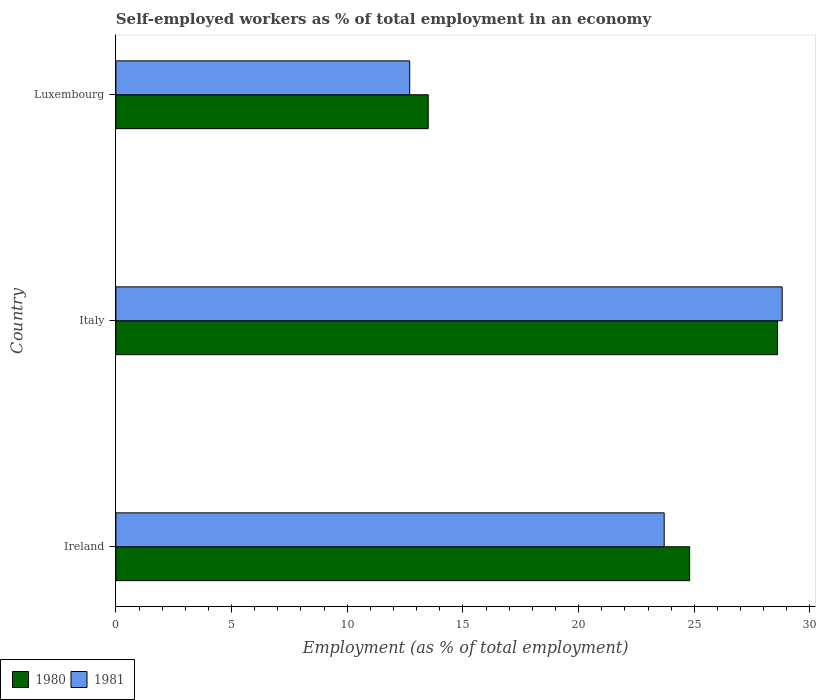How many different coloured bars are there?
Your response must be concise. 2. Are the number of bars per tick equal to the number of legend labels?
Provide a succinct answer. Yes. Are the number of bars on each tick of the Y-axis equal?
Ensure brevity in your answer.  Yes. What is the percentage of self-employed workers in 1980 in Italy?
Give a very brief answer. 28.6. Across all countries, what is the maximum percentage of self-employed workers in 1981?
Make the answer very short. 28.8. Across all countries, what is the minimum percentage of self-employed workers in 1980?
Provide a succinct answer. 13.5. In which country was the percentage of self-employed workers in 1980 maximum?
Keep it short and to the point. Italy. In which country was the percentage of self-employed workers in 1980 minimum?
Offer a terse response. Luxembourg. What is the total percentage of self-employed workers in 1980 in the graph?
Ensure brevity in your answer.  66.9. What is the difference between the percentage of self-employed workers in 1980 in Ireland and that in Italy?
Your answer should be compact. -3.8. What is the difference between the percentage of self-employed workers in 1981 in Luxembourg and the percentage of self-employed workers in 1980 in Italy?
Give a very brief answer. -15.9. What is the average percentage of self-employed workers in 1981 per country?
Ensure brevity in your answer.  21.73. What is the difference between the percentage of self-employed workers in 1980 and percentage of self-employed workers in 1981 in Italy?
Keep it short and to the point. -0.2. What is the ratio of the percentage of self-employed workers in 1980 in Italy to that in Luxembourg?
Provide a short and direct response. 2.12. Is the percentage of self-employed workers in 1981 in Italy less than that in Luxembourg?
Make the answer very short. No. What is the difference between the highest and the second highest percentage of self-employed workers in 1980?
Make the answer very short. 3.8. What is the difference between the highest and the lowest percentage of self-employed workers in 1980?
Offer a very short reply. 15.1. In how many countries, is the percentage of self-employed workers in 1981 greater than the average percentage of self-employed workers in 1981 taken over all countries?
Your answer should be very brief. 2. Is the sum of the percentage of self-employed workers in 1980 in Ireland and Luxembourg greater than the maximum percentage of self-employed workers in 1981 across all countries?
Your answer should be compact. Yes. What does the 1st bar from the top in Ireland represents?
Offer a very short reply. 1981. What does the 2nd bar from the bottom in Italy represents?
Make the answer very short. 1981. How many bars are there?
Give a very brief answer. 6. Are all the bars in the graph horizontal?
Give a very brief answer. Yes. Does the graph contain any zero values?
Your answer should be very brief. No. Does the graph contain grids?
Offer a very short reply. No. Where does the legend appear in the graph?
Keep it short and to the point. Bottom left. How are the legend labels stacked?
Provide a succinct answer. Horizontal. What is the title of the graph?
Offer a very short reply. Self-employed workers as % of total employment in an economy. What is the label or title of the X-axis?
Ensure brevity in your answer.  Employment (as % of total employment). What is the label or title of the Y-axis?
Your response must be concise. Country. What is the Employment (as % of total employment) of 1980 in Ireland?
Ensure brevity in your answer.  24.8. What is the Employment (as % of total employment) in 1981 in Ireland?
Keep it short and to the point. 23.7. What is the Employment (as % of total employment) in 1980 in Italy?
Keep it short and to the point. 28.6. What is the Employment (as % of total employment) of 1981 in Italy?
Provide a succinct answer. 28.8. What is the Employment (as % of total employment) of 1980 in Luxembourg?
Ensure brevity in your answer.  13.5. What is the Employment (as % of total employment) in 1981 in Luxembourg?
Your answer should be very brief. 12.7. Across all countries, what is the maximum Employment (as % of total employment) in 1980?
Give a very brief answer. 28.6. Across all countries, what is the maximum Employment (as % of total employment) of 1981?
Your answer should be compact. 28.8. Across all countries, what is the minimum Employment (as % of total employment) in 1980?
Provide a short and direct response. 13.5. Across all countries, what is the minimum Employment (as % of total employment) of 1981?
Ensure brevity in your answer.  12.7. What is the total Employment (as % of total employment) of 1980 in the graph?
Your answer should be very brief. 66.9. What is the total Employment (as % of total employment) in 1981 in the graph?
Your response must be concise. 65.2. What is the difference between the Employment (as % of total employment) in 1980 in Ireland and that in Italy?
Your answer should be very brief. -3.8. What is the difference between the Employment (as % of total employment) of 1981 in Ireland and that in Italy?
Provide a succinct answer. -5.1. What is the difference between the Employment (as % of total employment) in 1980 in Italy and that in Luxembourg?
Keep it short and to the point. 15.1. What is the difference between the Employment (as % of total employment) in 1981 in Italy and that in Luxembourg?
Make the answer very short. 16.1. What is the difference between the Employment (as % of total employment) of 1980 in Italy and the Employment (as % of total employment) of 1981 in Luxembourg?
Your answer should be very brief. 15.9. What is the average Employment (as % of total employment) in 1980 per country?
Provide a short and direct response. 22.3. What is the average Employment (as % of total employment) in 1981 per country?
Offer a very short reply. 21.73. What is the difference between the Employment (as % of total employment) of 1980 and Employment (as % of total employment) of 1981 in Ireland?
Your answer should be compact. 1.1. What is the difference between the Employment (as % of total employment) of 1980 and Employment (as % of total employment) of 1981 in Italy?
Offer a terse response. -0.2. What is the difference between the Employment (as % of total employment) in 1980 and Employment (as % of total employment) in 1981 in Luxembourg?
Give a very brief answer. 0.8. What is the ratio of the Employment (as % of total employment) of 1980 in Ireland to that in Italy?
Your answer should be very brief. 0.87. What is the ratio of the Employment (as % of total employment) of 1981 in Ireland to that in Italy?
Your answer should be compact. 0.82. What is the ratio of the Employment (as % of total employment) of 1980 in Ireland to that in Luxembourg?
Keep it short and to the point. 1.84. What is the ratio of the Employment (as % of total employment) in 1981 in Ireland to that in Luxembourg?
Make the answer very short. 1.87. What is the ratio of the Employment (as % of total employment) of 1980 in Italy to that in Luxembourg?
Provide a short and direct response. 2.12. What is the ratio of the Employment (as % of total employment) of 1981 in Italy to that in Luxembourg?
Make the answer very short. 2.27. What is the difference between the highest and the lowest Employment (as % of total employment) in 1981?
Provide a succinct answer. 16.1. 